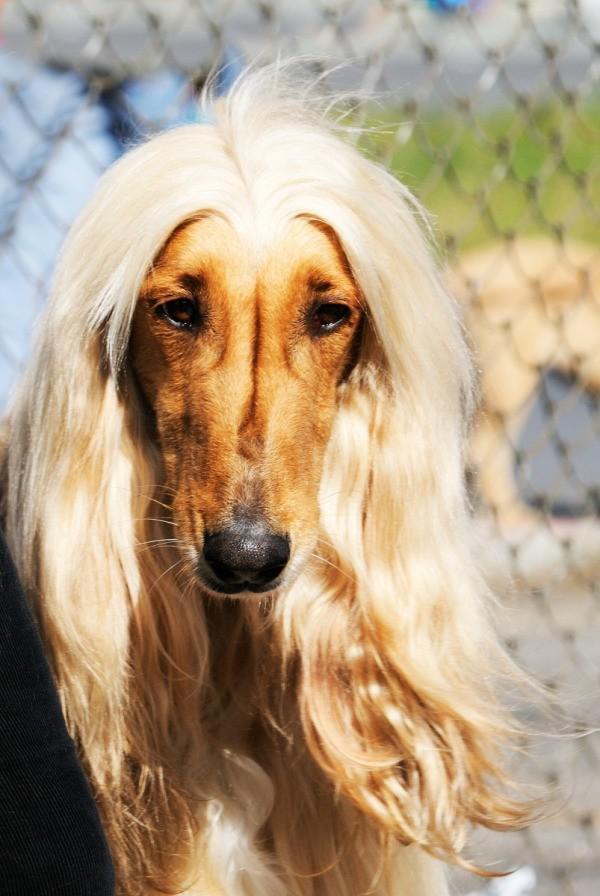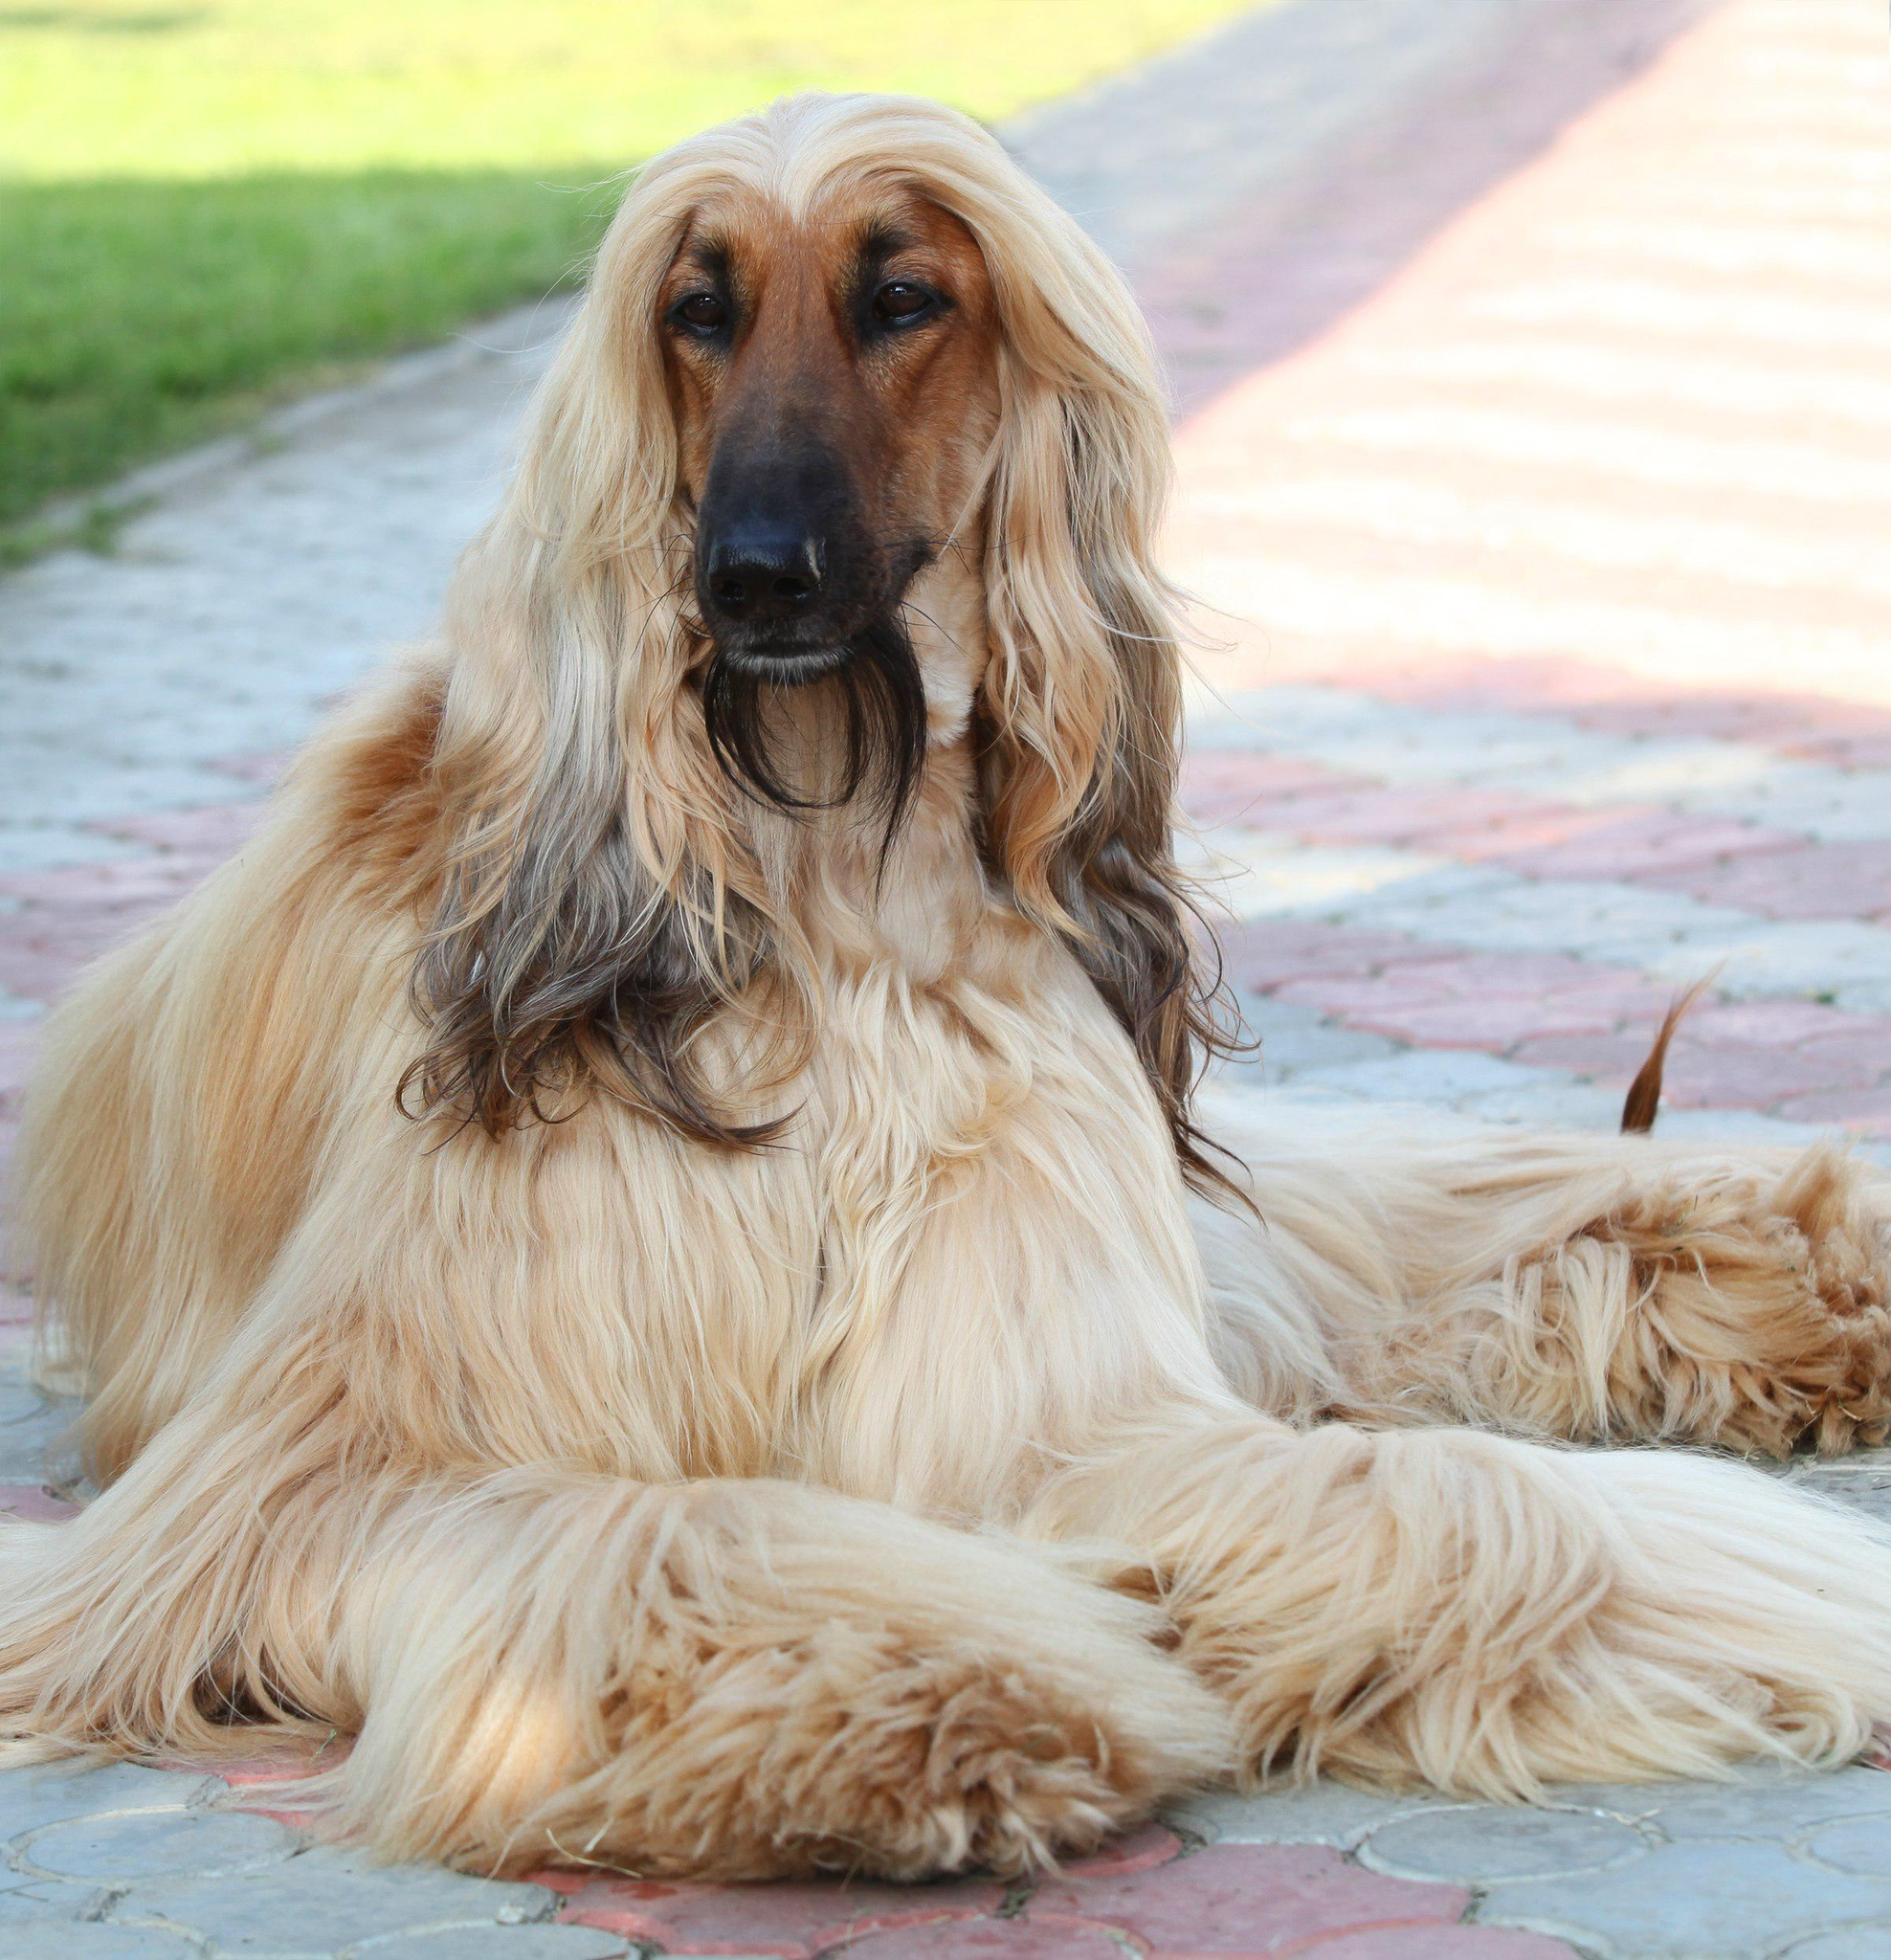The first image is the image on the left, the second image is the image on the right. Evaluate the accuracy of this statement regarding the images: "The afghan hound in the left image is looking at the camera as the picture is taken.". Is it true? Answer yes or no. Yes. 